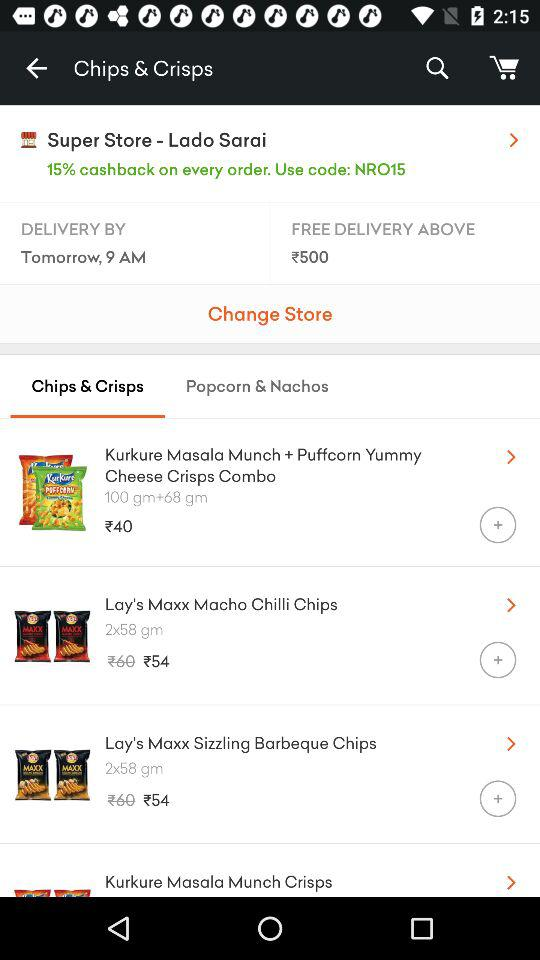What's the value of the minimum order for free delivery? The value of the minimum order for free delivery is ₹500. 